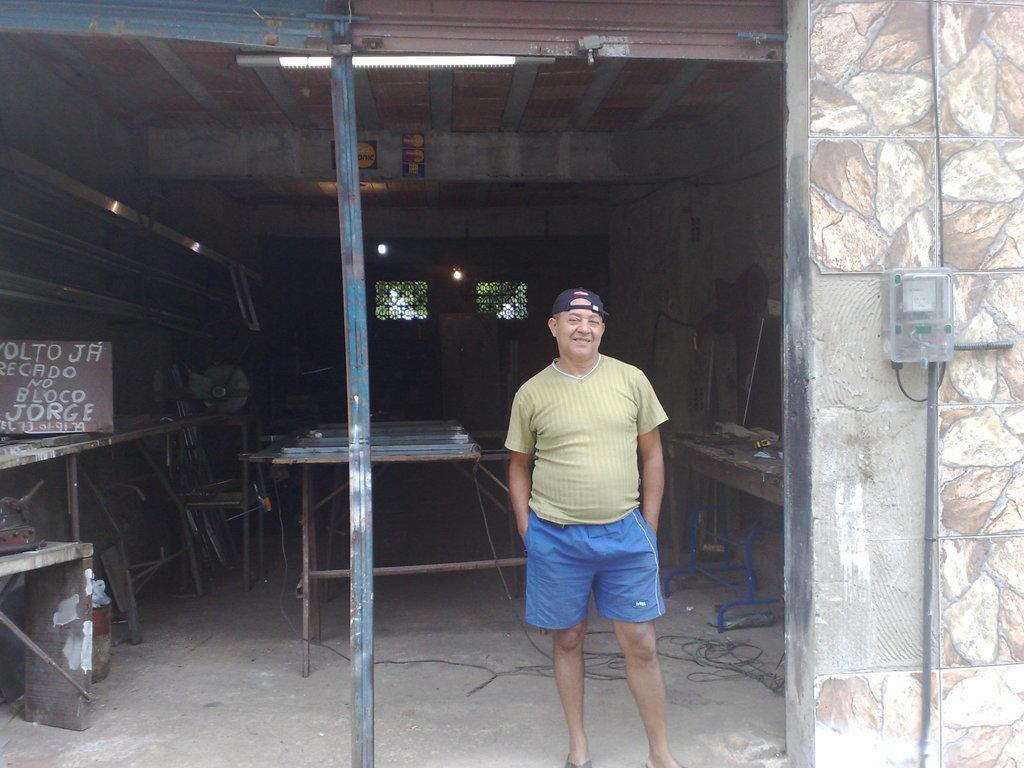<image>
Render a clear and concise summary of the photo. A man stands in a open doorway, next to him is a sign about Recado, no Bloco Jorge. 